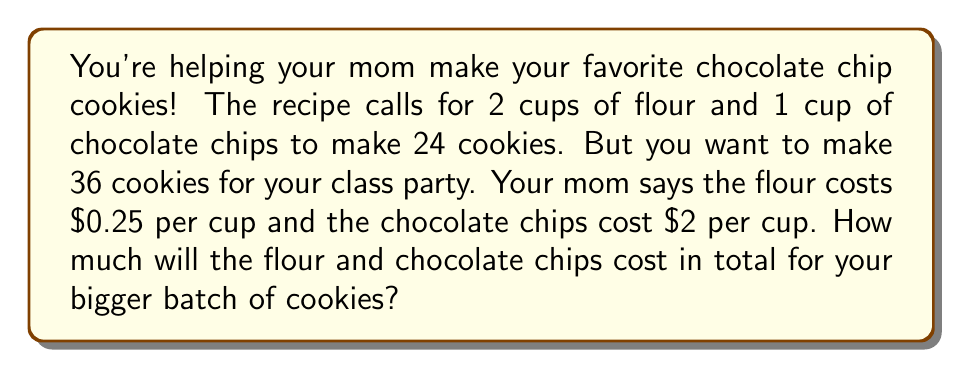What is the answer to this math problem? Let's break this down step-by-step:

1. First, we need to find out how much of each ingredient we need for 36 cookies.

   Original recipe: 24 cookies
   New batch: 36 cookies

   We can set up a proportion:
   $$ \frac{24 \text{ cookies}}{2 \text{ cups flour}} = \frac{36 \text{ cookies}}{x \text{ cups flour}} $$

   Cross multiply: $24x = 36 * 2$
   Solve for x: $x = \frac{36 * 2}{24} = 3$ cups of flour

   Do the same for chocolate chips:
   $$ \frac{24 \text{ cookies}}{1 \text{ cup chips}} = \frac{36 \text{ cookies}}{y \text{ cups chips}} $$

   Solve for y: $y = \frac{36 * 1}{24} = 1.5$ cups of chocolate chips

2. Now, let's calculate the cost:

   Flour: $3 \text{ cups} * $0.25 \text{ per cup} = $0.75$
   Chocolate chips: $1.5 \text{ cups} * $2 \text{ per cup} = $3

3. Add these together:
   $$ $0.75 + $3 = $3.75 $$
Answer: The total cost for flour and chocolate chips for 36 cookies is $3.75. 